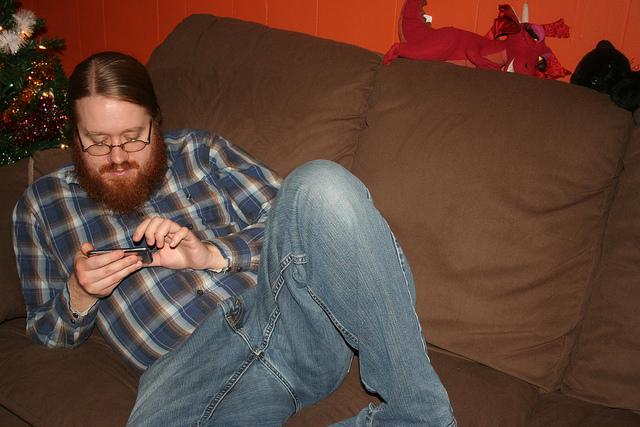What animal is the red stuffed animal? dragon 